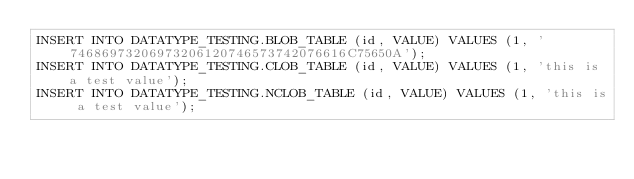<code> <loc_0><loc_0><loc_500><loc_500><_SQL_>INSERT INTO DATATYPE_TESTING.BLOB_TABLE (id, VALUE) VALUES (1, '74686973206973206120746573742076616C75650A');
INSERT INTO DATATYPE_TESTING.CLOB_TABLE (id, VALUE) VALUES (1, 'this is a test value');
INSERT INTO DATATYPE_TESTING.NCLOB_TABLE (id, VALUE) VALUES (1, 'this is a test value');
</code> 